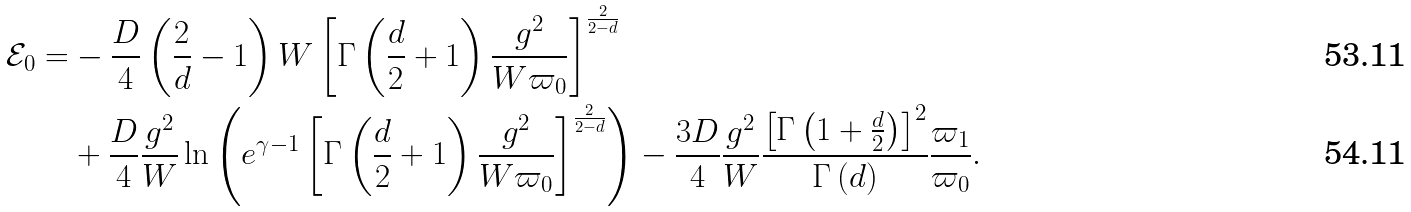<formula> <loc_0><loc_0><loc_500><loc_500>\mathcal { E } _ { 0 } = & - \frac { D } { 4 } \left ( \frac { 2 } { d } - 1 \right ) W \left [ \Gamma \left ( \frac { d } { 2 } + 1 \right ) \frac { g ^ { 2 } } { W \varpi _ { 0 } } \right ] ^ { \frac { 2 } { 2 - d } } \\ & + \frac { D } { 4 } \frac { g ^ { 2 } } { W } \ln \left ( e ^ { \gamma - 1 } \left [ \Gamma \left ( \frac { d } { 2 } + 1 \right ) \frac { g ^ { 2 } } { W \varpi _ { 0 } } \right ] ^ { \frac { 2 } { 2 - d } } \right ) - \frac { 3 D } { 4 } \frac { g ^ { 2 } } { W } \frac { \left [ \Gamma \left ( 1 + \frac { d } { 2 } \right ) \right ] ^ { 2 } } { \Gamma \left ( d \right ) } \frac { \varpi _ { 1 } } { \varpi _ { 0 } } .</formula> 